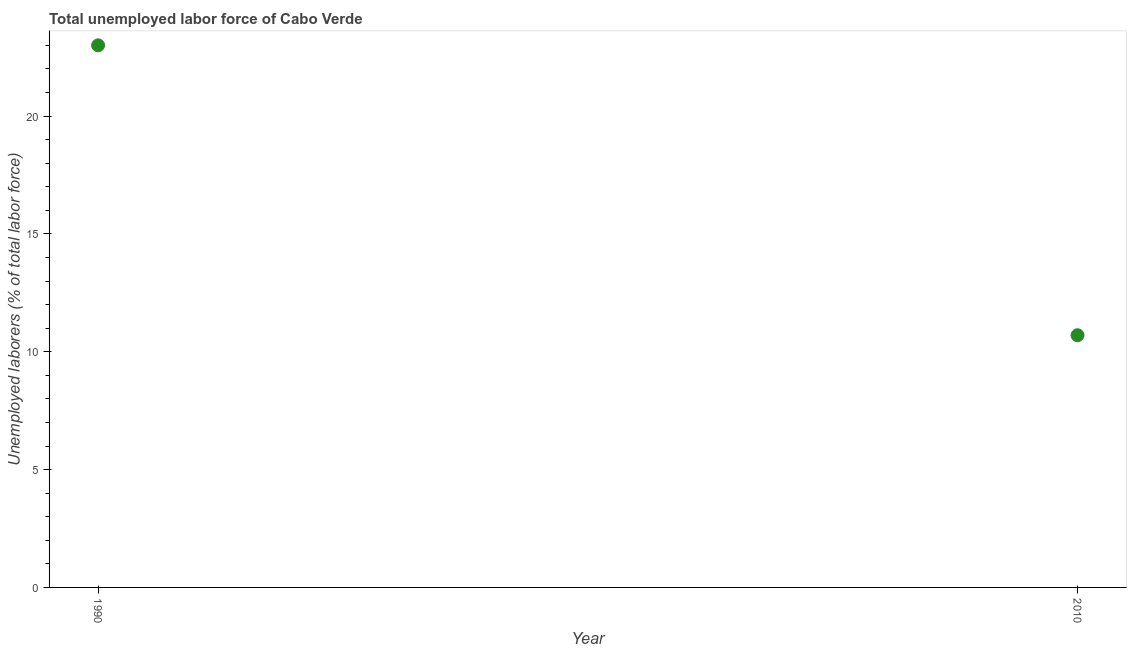Across all years, what is the minimum total unemployed labour force?
Keep it short and to the point. 10.7. What is the sum of the total unemployed labour force?
Your answer should be very brief. 33.7. What is the difference between the total unemployed labour force in 1990 and 2010?
Offer a very short reply. 12.3. What is the average total unemployed labour force per year?
Ensure brevity in your answer.  16.85. What is the median total unemployed labour force?
Your answer should be very brief. 16.85. In how many years, is the total unemployed labour force greater than 17 %?
Ensure brevity in your answer.  1. Do a majority of the years between 1990 and 2010 (inclusive) have total unemployed labour force greater than 18 %?
Provide a short and direct response. No. What is the ratio of the total unemployed labour force in 1990 to that in 2010?
Offer a terse response. 2.15. Is the total unemployed labour force in 1990 less than that in 2010?
Ensure brevity in your answer.  No. How many dotlines are there?
Offer a very short reply. 1. Does the graph contain any zero values?
Provide a succinct answer. No. What is the title of the graph?
Offer a very short reply. Total unemployed labor force of Cabo Verde. What is the label or title of the X-axis?
Your answer should be compact. Year. What is the label or title of the Y-axis?
Give a very brief answer. Unemployed laborers (% of total labor force). What is the Unemployed laborers (% of total labor force) in 1990?
Your answer should be very brief. 23. What is the Unemployed laborers (% of total labor force) in 2010?
Provide a short and direct response. 10.7. What is the difference between the Unemployed laborers (% of total labor force) in 1990 and 2010?
Your response must be concise. 12.3. What is the ratio of the Unemployed laborers (% of total labor force) in 1990 to that in 2010?
Give a very brief answer. 2.15. 